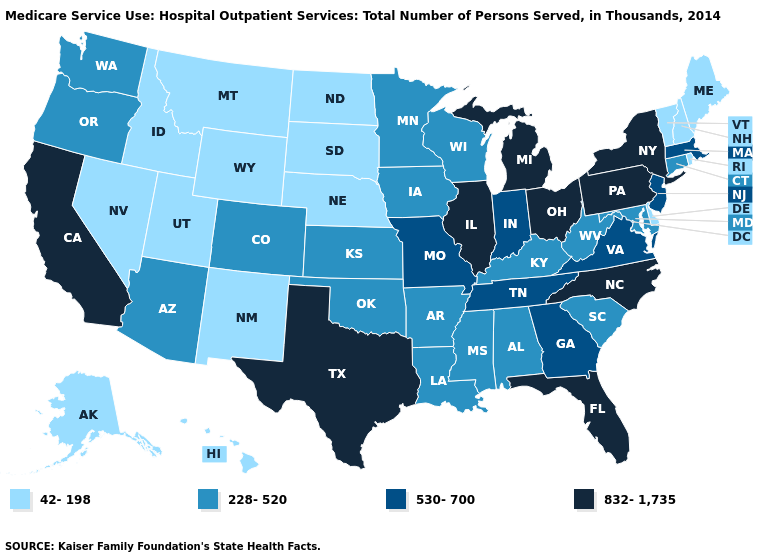Among the states that border Tennessee , which have the lowest value?
Short answer required. Alabama, Arkansas, Kentucky, Mississippi. What is the lowest value in states that border Louisiana?
Short answer required. 228-520. Does the map have missing data?
Be succinct. No. Name the states that have a value in the range 832-1,735?
Quick response, please. California, Florida, Illinois, Michigan, New York, North Carolina, Ohio, Pennsylvania, Texas. Is the legend a continuous bar?
Be succinct. No. What is the value of Hawaii?
Give a very brief answer. 42-198. What is the value of Montana?
Keep it brief. 42-198. What is the lowest value in the South?
Short answer required. 42-198. Name the states that have a value in the range 42-198?
Give a very brief answer. Alaska, Delaware, Hawaii, Idaho, Maine, Montana, Nebraska, Nevada, New Hampshire, New Mexico, North Dakota, Rhode Island, South Dakota, Utah, Vermont, Wyoming. Among the states that border Tennessee , does Alabama have the highest value?
Be succinct. No. Among the states that border Connecticut , does Massachusetts have the lowest value?
Quick response, please. No. Which states have the highest value in the USA?
Give a very brief answer. California, Florida, Illinois, Michigan, New York, North Carolina, Ohio, Pennsylvania, Texas. What is the value of Nebraska?
Answer briefly. 42-198. Does New Jersey have the lowest value in the Northeast?
Concise answer only. No. What is the highest value in the Northeast ?
Be succinct. 832-1,735. 